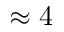<formula> <loc_0><loc_0><loc_500><loc_500>\approx 4</formula> 